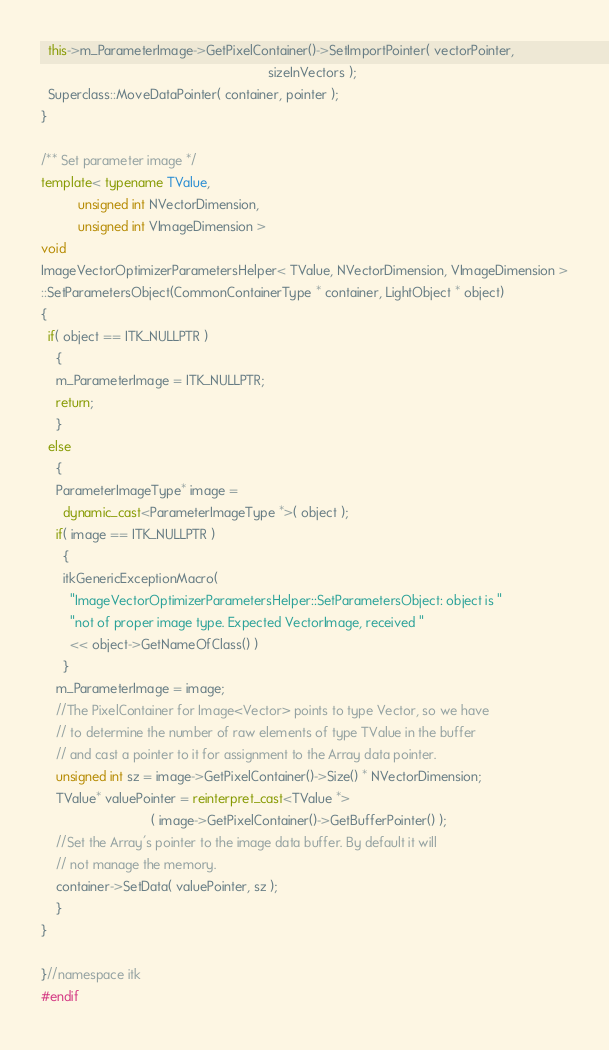Convert code to text. <code><loc_0><loc_0><loc_500><loc_500><_C++_>  this->m_ParameterImage->GetPixelContainer()->SetImportPointer( vectorPointer,
                                                              sizeInVectors );
  Superclass::MoveDataPointer( container, pointer );
}

/** Set parameter image */
template< typename TValue,
          unsigned int NVectorDimension,
          unsigned int VImageDimension >
void
ImageVectorOptimizerParametersHelper< TValue, NVectorDimension, VImageDimension >
::SetParametersObject(CommonContainerType * container, LightObject * object)
{
  if( object == ITK_NULLPTR )
    {
    m_ParameterImage = ITK_NULLPTR;
    return;
    }
  else
    {
    ParameterImageType* image =
      dynamic_cast<ParameterImageType *>( object );
    if( image == ITK_NULLPTR )
      {
      itkGenericExceptionMacro(
        "ImageVectorOptimizerParametersHelper::SetParametersObject: object is "
        "not of proper image type. Expected VectorImage, received "
        << object->GetNameOfClass() )
      }
    m_ParameterImage = image;
    //The PixelContainer for Image<Vector> points to type Vector, so we have
    // to determine the number of raw elements of type TValue in the buffer
    // and cast a pointer to it for assignment to the Array data pointer.
    unsigned int sz = image->GetPixelContainer()->Size() * NVectorDimension;
    TValue* valuePointer = reinterpret_cast<TValue *>
                              ( image->GetPixelContainer()->GetBufferPointer() );
    //Set the Array's pointer to the image data buffer. By default it will
    // not manage the memory.
    container->SetData( valuePointer, sz );
    }
}

}//namespace itk
#endif
</code> 